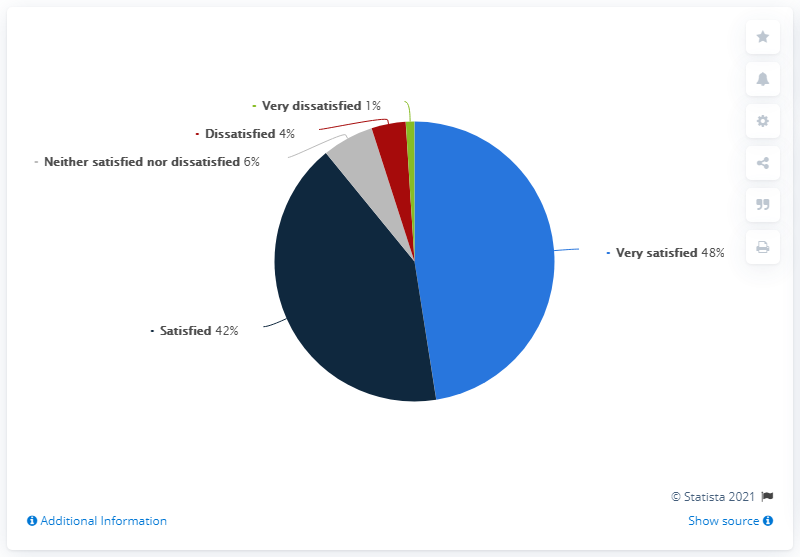Identify some key points in this picture. Out of the 48 people surveyed, 48% reported being very satisfied. The color red indicates dissatisfaction, as stated in the given sentence. 